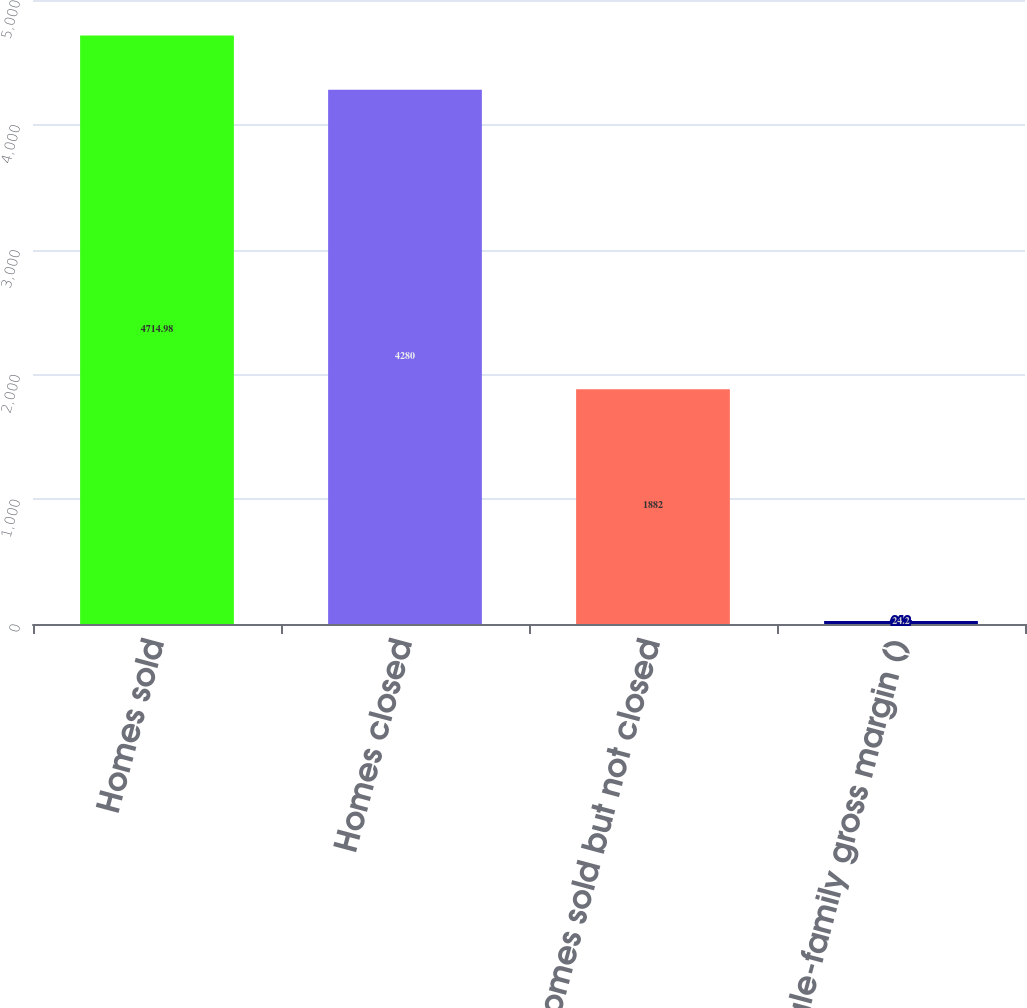<chart> <loc_0><loc_0><loc_500><loc_500><bar_chart><fcel>Homes sold<fcel>Homes closed<fcel>Homes sold but not closed<fcel>Single-family gross margin ()<nl><fcel>4714.98<fcel>4280<fcel>1882<fcel>24.2<nl></chart> 